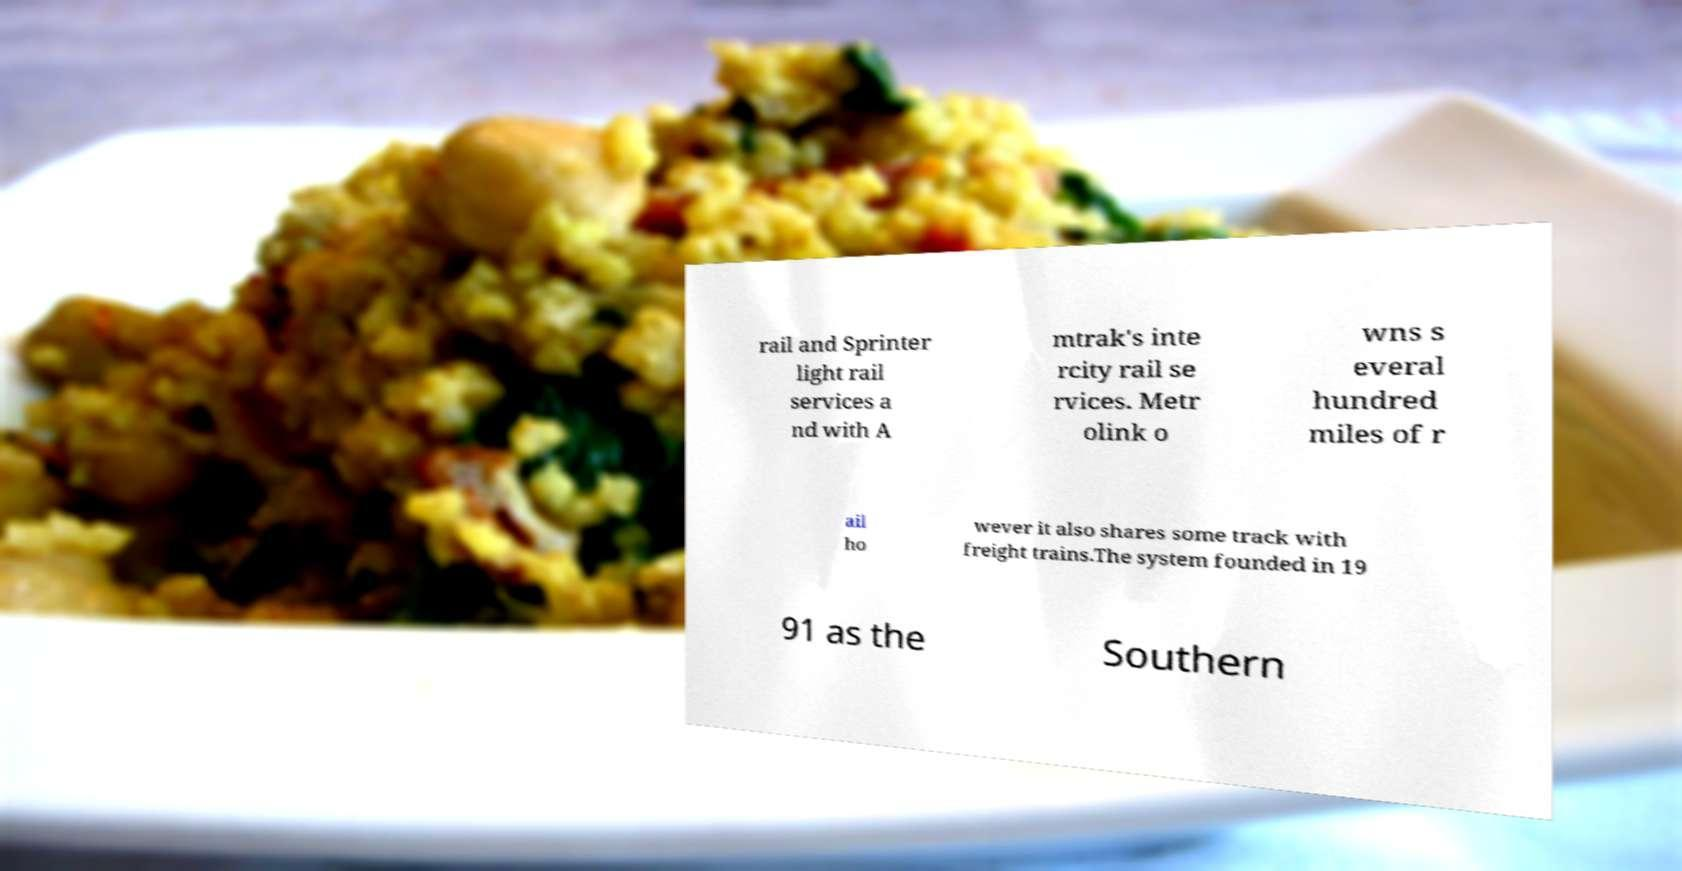Could you assist in decoding the text presented in this image and type it out clearly? rail and Sprinter light rail services a nd with A mtrak's inte rcity rail se rvices. Metr olink o wns s everal hundred miles of r ail ho wever it also shares some track with freight trains.The system founded in 19 91 as the Southern 